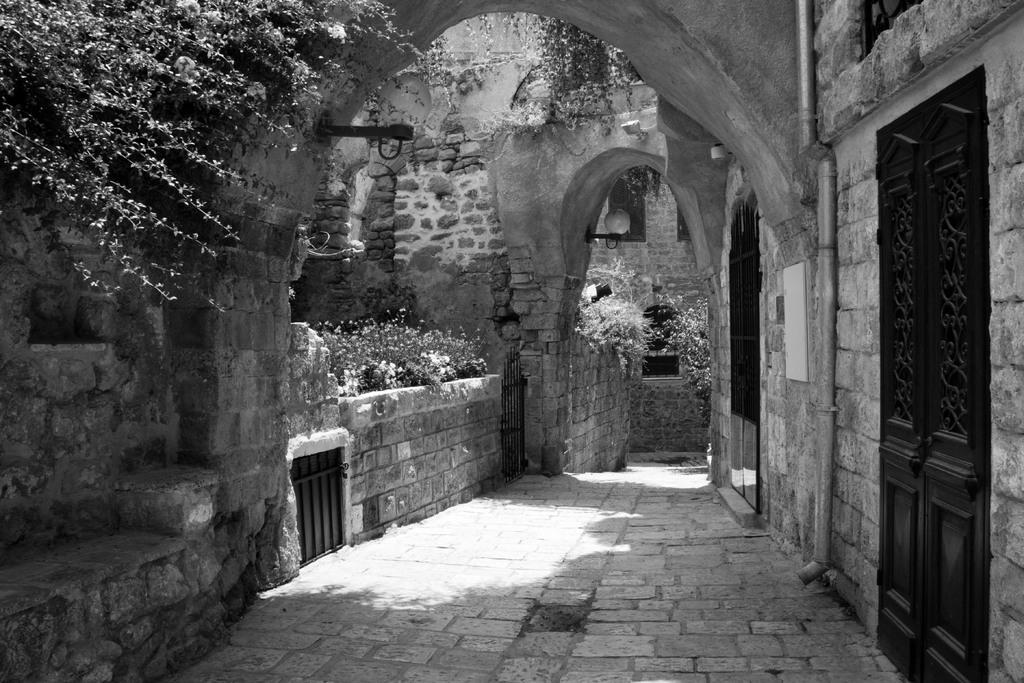What type of structure is visible in the image? There is a stone construction in the image, which forms a fence. What type of vegetation can be seen in the image? There is grass in the image, and there is also a tree present. What other objects can be seen in the image? There is a pipe, a footpath, and a door visible in the image. How many women are mining for bones in the image? There are no women or bones present in the image; it features a stone fence, grass, a tree, a pipe, a footpath, and a door. 